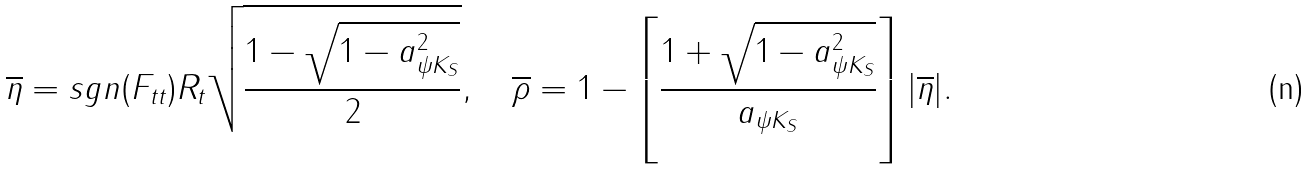<formula> <loc_0><loc_0><loc_500><loc_500>\overline { \eta } = s g n ( F _ { t t } ) R _ { t } \sqrt { \frac { 1 - \sqrt { 1 - a _ { \psi K _ { S } } ^ { 2 } } } { 2 } } , \quad \overline { \rho } = 1 - \left [ \frac { 1 + \sqrt { 1 - a _ { \psi K _ { S } } ^ { 2 } } } { a _ { \psi K _ { S } } } \right ] | \overline { \eta } | .</formula> 